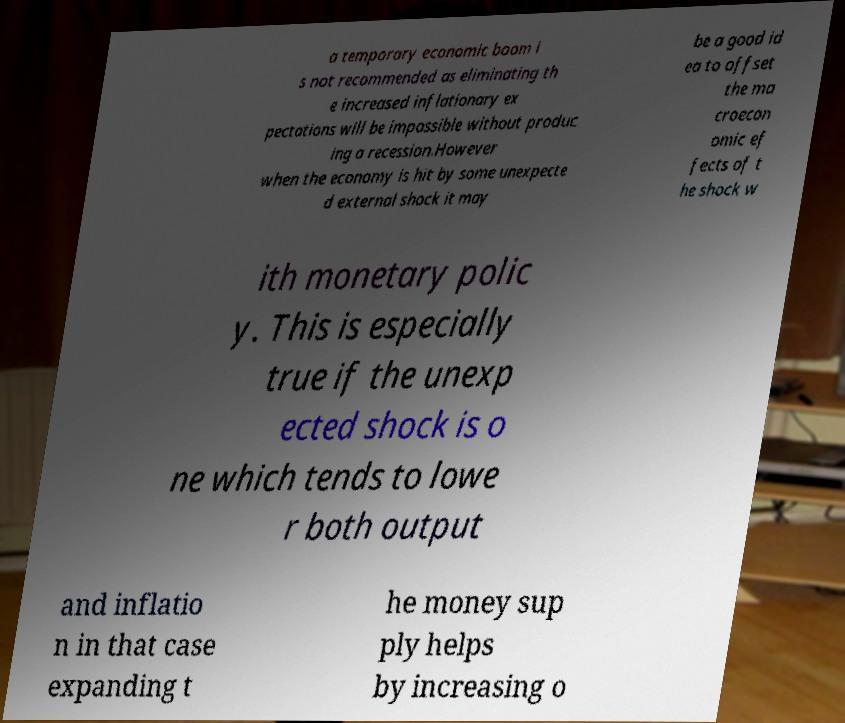Please read and relay the text visible in this image. What does it say? a temporary economic boom i s not recommended as eliminating th e increased inflationary ex pectations will be impossible without produc ing a recession.However when the economy is hit by some unexpecte d external shock it may be a good id ea to offset the ma croecon omic ef fects of t he shock w ith monetary polic y. This is especially true if the unexp ected shock is o ne which tends to lowe r both output and inflatio n in that case expanding t he money sup ply helps by increasing o 